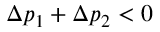Convert formula to latex. <formula><loc_0><loc_0><loc_500><loc_500>\Delta p _ { 1 } + \Delta p _ { 2 } < 0</formula> 